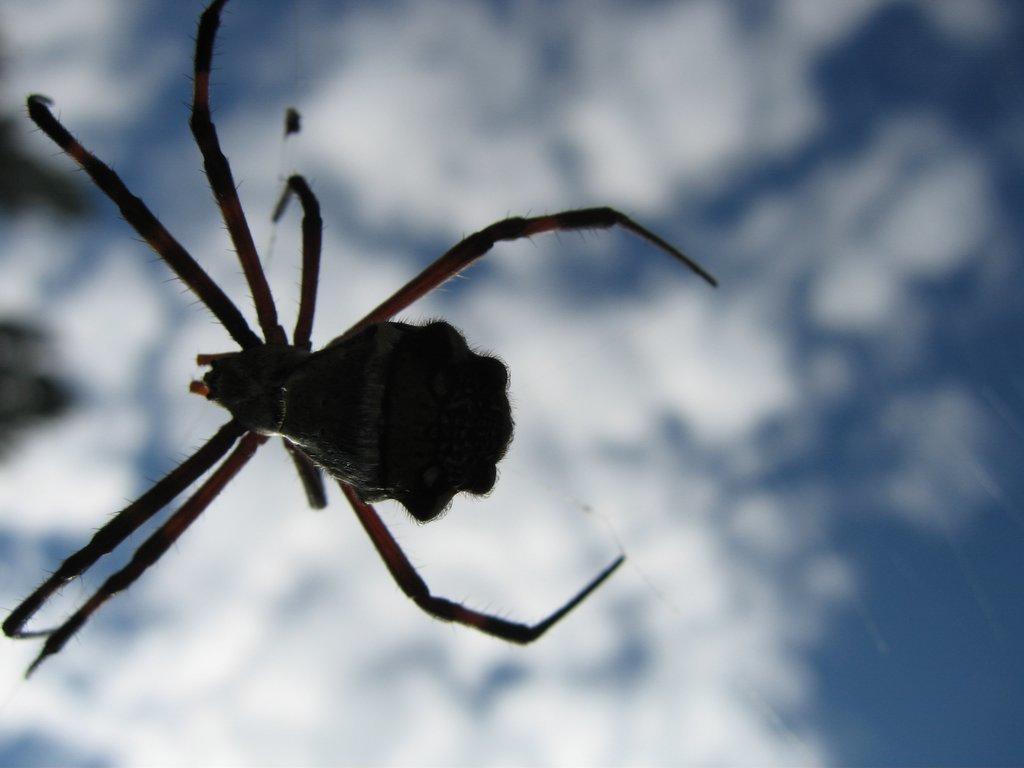Please provide a concise description of this image. In this image we can see a spider on the web. On the backside we can see the sky which looks cloudy. 